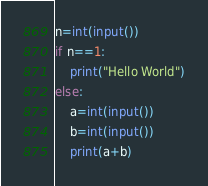<code> <loc_0><loc_0><loc_500><loc_500><_Python_>n=int(input())
if n==1:
    print("Hello World")
else:
    a=int(input())
    b=int(input())
    print(a+b)</code> 